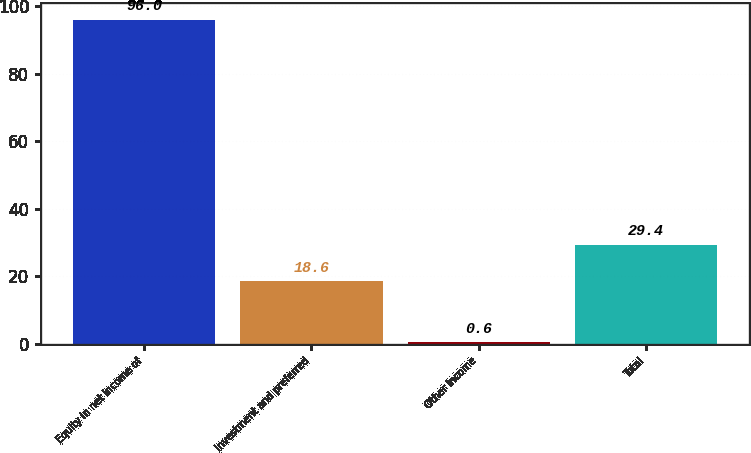Convert chart. <chart><loc_0><loc_0><loc_500><loc_500><bar_chart><fcel>Equity in net income of<fcel>Investment and preferred<fcel>Other income<fcel>Total<nl><fcel>96<fcel>18.6<fcel>0.6<fcel>29.4<nl></chart> 